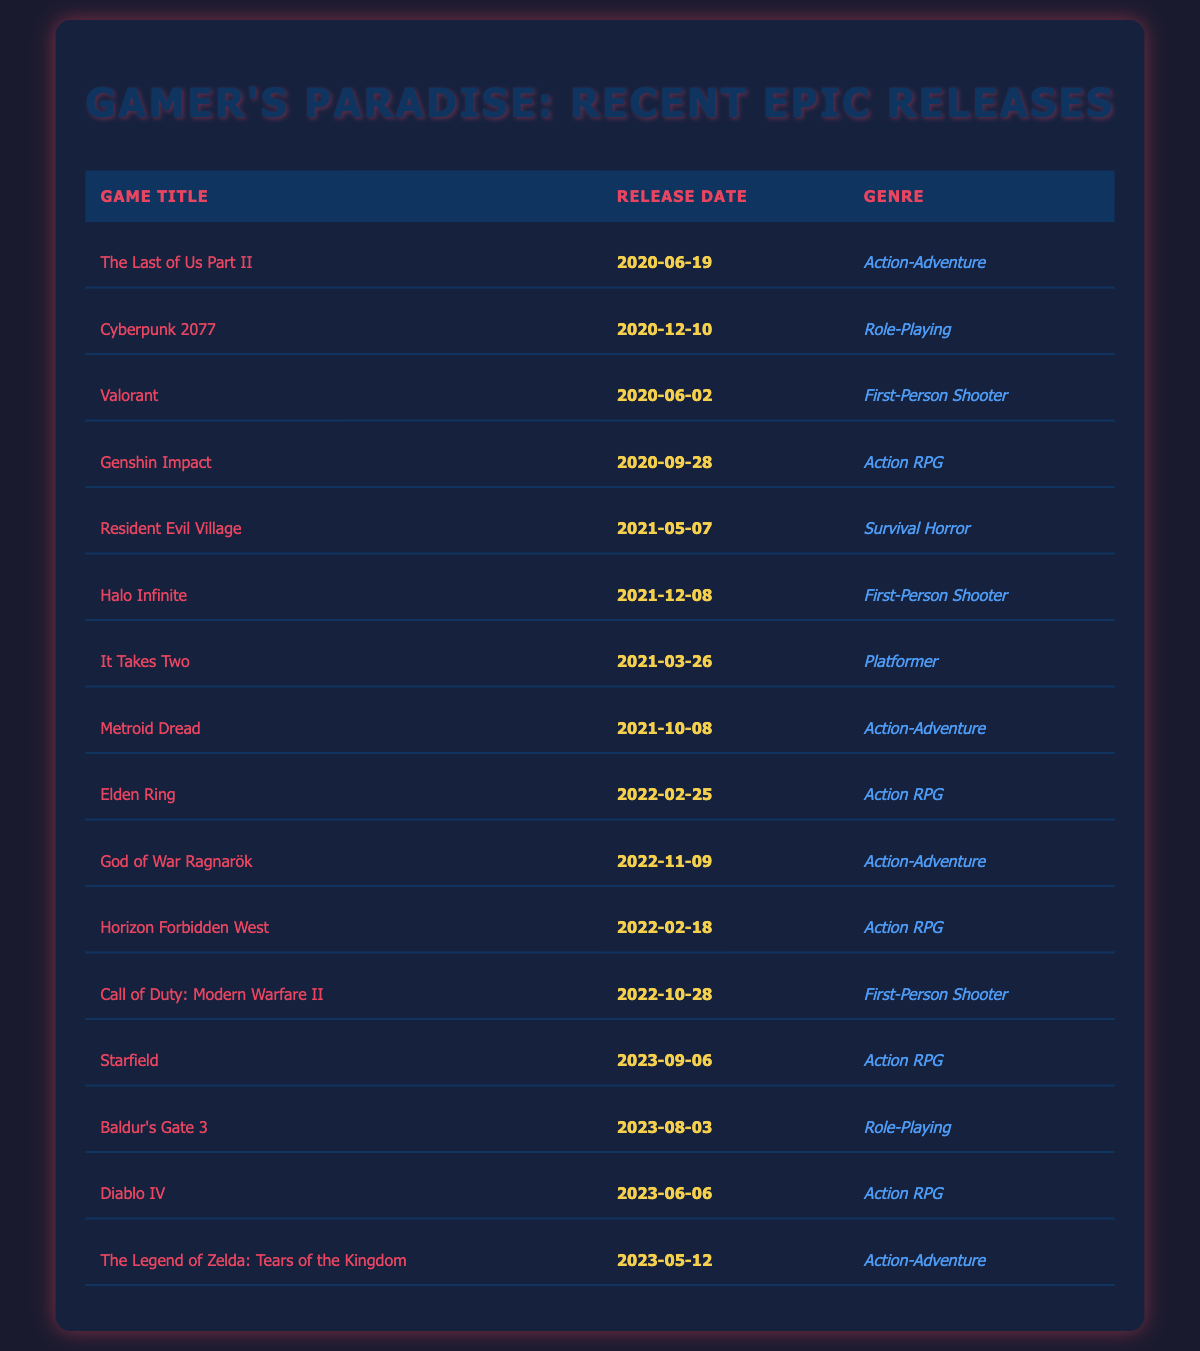What is the release date of "Elden Ring"? By looking at the table, I can find the row for "Elden Ring" and see the associated release date. It lists February 25, 2022.
Answer: February 25, 2022 Which game was released in 2021 and belongs to the genre "First-Person Shooter"? I can check the table for games released in 2021 and look for the genre category. "Halo Infinite" matches both criteria with a release date of December 8, 2021.
Answer: Halo Infinite How many Action RPG games were released between 2022 and 2023? I will count the number of games listed as "Action RPG" in the release years of 2022 and 2023. The games are "Horizon Forbidden West," "Elden Ring," "Starfield," "Baldur's Gate 3," and "Diablo IV," which total five games.
Answer: 5 Is "Resident Evil Village" released after "Cyberpunk 2077"? I can see that "Resident Evil Village" was released on May 7, 2021, whereas "Cyberpunk 2077" was released on December 10, 2020. Since May 2021 is after December 2020, the answer is yes.
Answer: Yes What genre has the most games released in 2022? First, I check how many games of each genre were released in 2022 from the table. The genres and their counts are: Action RPG (3), Action-Adventure (2), First-Person Shooter (1). The genre "Action RPG" has the highest count with three games.
Answer: Action RPG How many months apart were "The Last of Us Part II" and "The Legend of Zelda: Tears of the Kingdom" released? I check the release dates: "The Last of Us Part II" was released on June 19, 2020, and "The Legend of Zelda: Tears of the Kingdom" was released on May 12, 2023. The difference is almost 35 months (2 years and 11 months).
Answer: 35 months Which game released in 2023 has the earliest release date? I review the games released in 2023 in the table. The release dates are for "Baldur's Gate 3" (August 3, 2023), "Diablo IV" (June 6, 2023), and "Starfield" (September 6, 2023). The earliest is "Diablo IV."
Answer: Diablo IV Are there more games in the "Action-Adventure" genre than in the "Survival Horror" genre? I count the games: "Action-Adventure" has four releases ("The Last of Us Part II," "Metroid Dread," "God of War Ragnarök," and "The Legend of Zelda: Tears of the Kingdom"), while "Survival Horror" has only one game ("Resident Evil Village"). Yes, there are more.
Answer: Yes What percentage of the games listed are First-Person Shooters? I first count the total games (15) and the First-Person Shooter games (4: "Valorant," "Halo Infinite," "Call of Duty: Modern Warfare II"). The percentage is (4/15) * 100 = 26.67%.
Answer: Approximately 26.67% Is "Genshin Impact" an Action RPG? I can find "Genshin Impact" in the table, and it is listed under the "Action RPG" genre. Therefore, it is true that it is an Action RPG.
Answer: Yes 